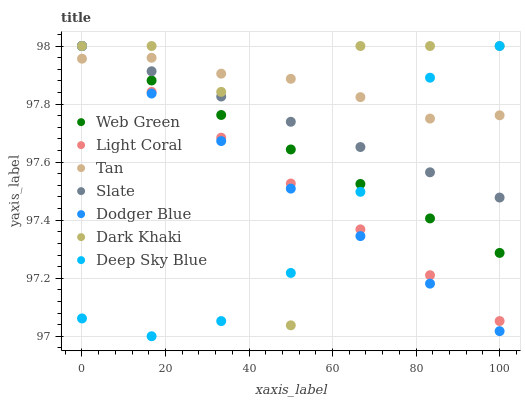Does Deep Sky Blue have the minimum area under the curve?
Answer yes or no. Yes. Does Tan have the maximum area under the curve?
Answer yes or no. Yes. Does Slate have the minimum area under the curve?
Answer yes or no. No. Does Slate have the maximum area under the curve?
Answer yes or no. No. Is Light Coral the smoothest?
Answer yes or no. Yes. Is Dark Khaki the roughest?
Answer yes or no. Yes. Is Slate the smoothest?
Answer yes or no. No. Is Slate the roughest?
Answer yes or no. No. Does Deep Sky Blue have the lowest value?
Answer yes or no. Yes. Does Slate have the lowest value?
Answer yes or no. No. Does Deep Sky Blue have the highest value?
Answer yes or no. Yes. Does Tan have the highest value?
Answer yes or no. No. Does Dodger Blue intersect Dark Khaki?
Answer yes or no. Yes. Is Dodger Blue less than Dark Khaki?
Answer yes or no. No. Is Dodger Blue greater than Dark Khaki?
Answer yes or no. No. 